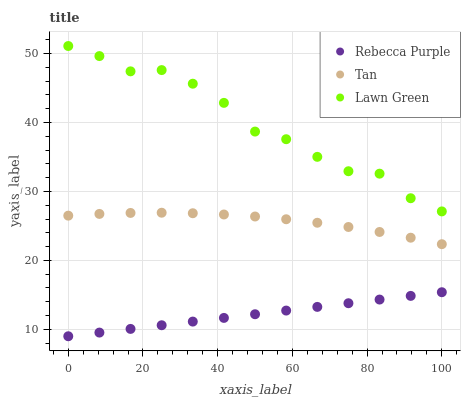Does Rebecca Purple have the minimum area under the curve?
Answer yes or no. Yes. Does Lawn Green have the maximum area under the curve?
Answer yes or no. Yes. Does Tan have the minimum area under the curve?
Answer yes or no. No. Does Tan have the maximum area under the curve?
Answer yes or no. No. Is Rebecca Purple the smoothest?
Answer yes or no. Yes. Is Lawn Green the roughest?
Answer yes or no. Yes. Is Tan the smoothest?
Answer yes or no. No. Is Tan the roughest?
Answer yes or no. No. Does Rebecca Purple have the lowest value?
Answer yes or no. Yes. Does Tan have the lowest value?
Answer yes or no. No. Does Lawn Green have the highest value?
Answer yes or no. Yes. Does Tan have the highest value?
Answer yes or no. No. Is Tan less than Lawn Green?
Answer yes or no. Yes. Is Tan greater than Rebecca Purple?
Answer yes or no. Yes. Does Tan intersect Lawn Green?
Answer yes or no. No. 